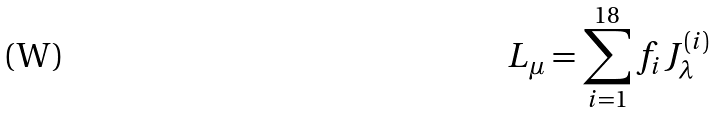Convert formula to latex. <formula><loc_0><loc_0><loc_500><loc_500>L _ { \mu } = \sum _ { i = 1 } ^ { 1 8 } f _ { i } J _ { \lambda } ^ { ( i ) }</formula> 